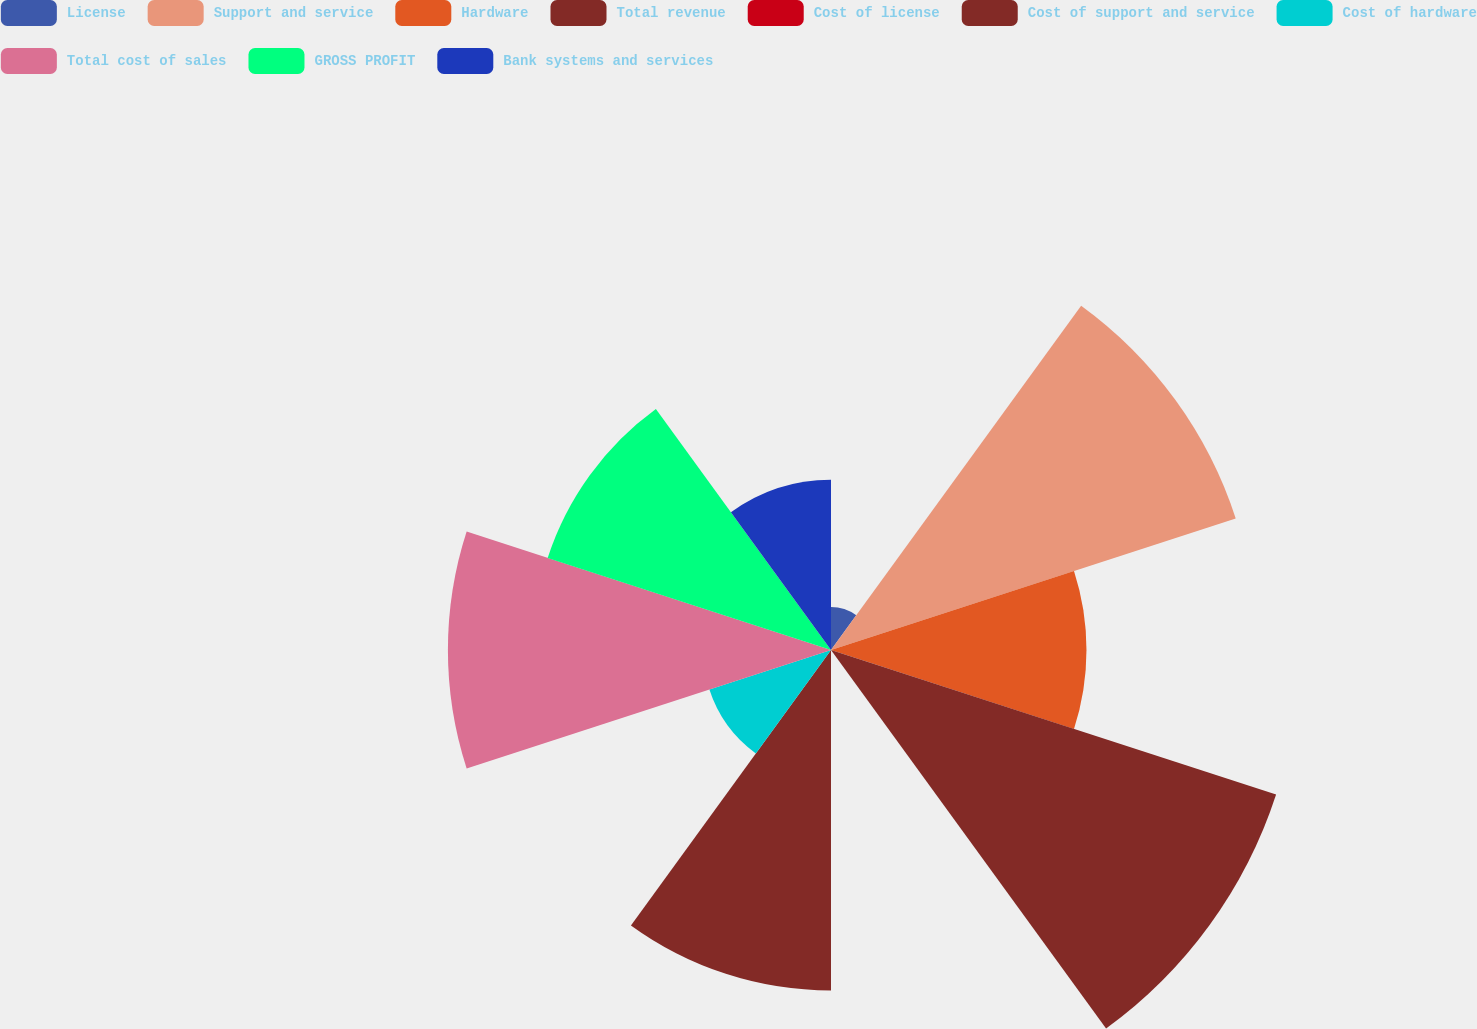Convert chart. <chart><loc_0><loc_0><loc_500><loc_500><pie_chart><fcel>License<fcel>Support and service<fcel>Hardware<fcel>Total revenue<fcel>Cost of license<fcel>Cost of support and service<fcel>Cost of hardware<fcel>Total cost of sales<fcel>GROSS PROFIT<fcel>Bank systems and services<nl><fcel>1.71%<fcel>16.94%<fcel>10.17%<fcel>18.63%<fcel>0.01%<fcel>13.55%<fcel>5.09%<fcel>15.25%<fcel>11.86%<fcel>6.78%<nl></chart> 